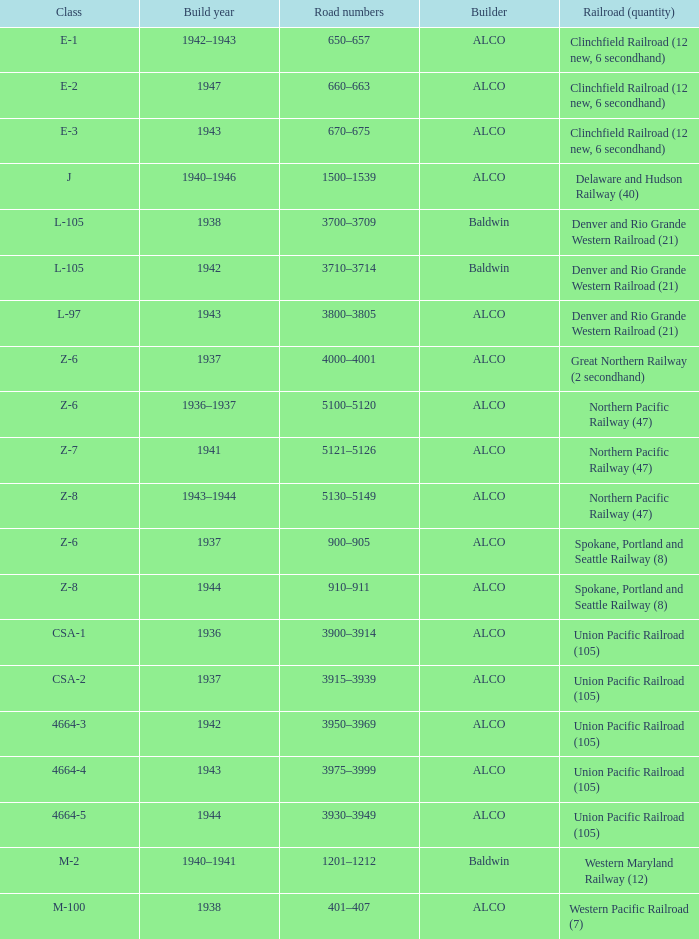What is the road numbers when the builder is alco, the railroad (quantity) is union pacific railroad (105) and the class is csa-2? 3915–3939. 